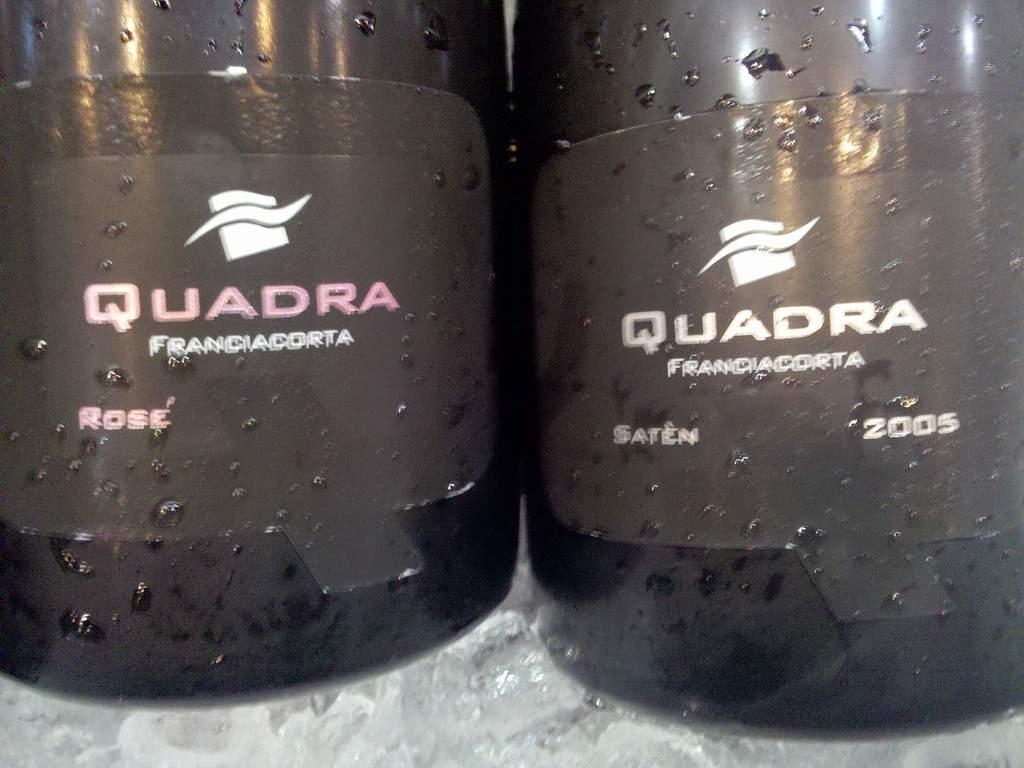What is located at the bottom of the image? There is a table at the bottom of the image. What objects are on the table? There are two bottles on the table. What can be seen on the bottles? The bottles have alphabets and numbers on them. What type of nation is depicted on the bottles in the image? There is no nation depicted on the bottles in the image; they have alphabets and numbers on them. How many bananas are visible in the image? There are no bananas present in the image. 